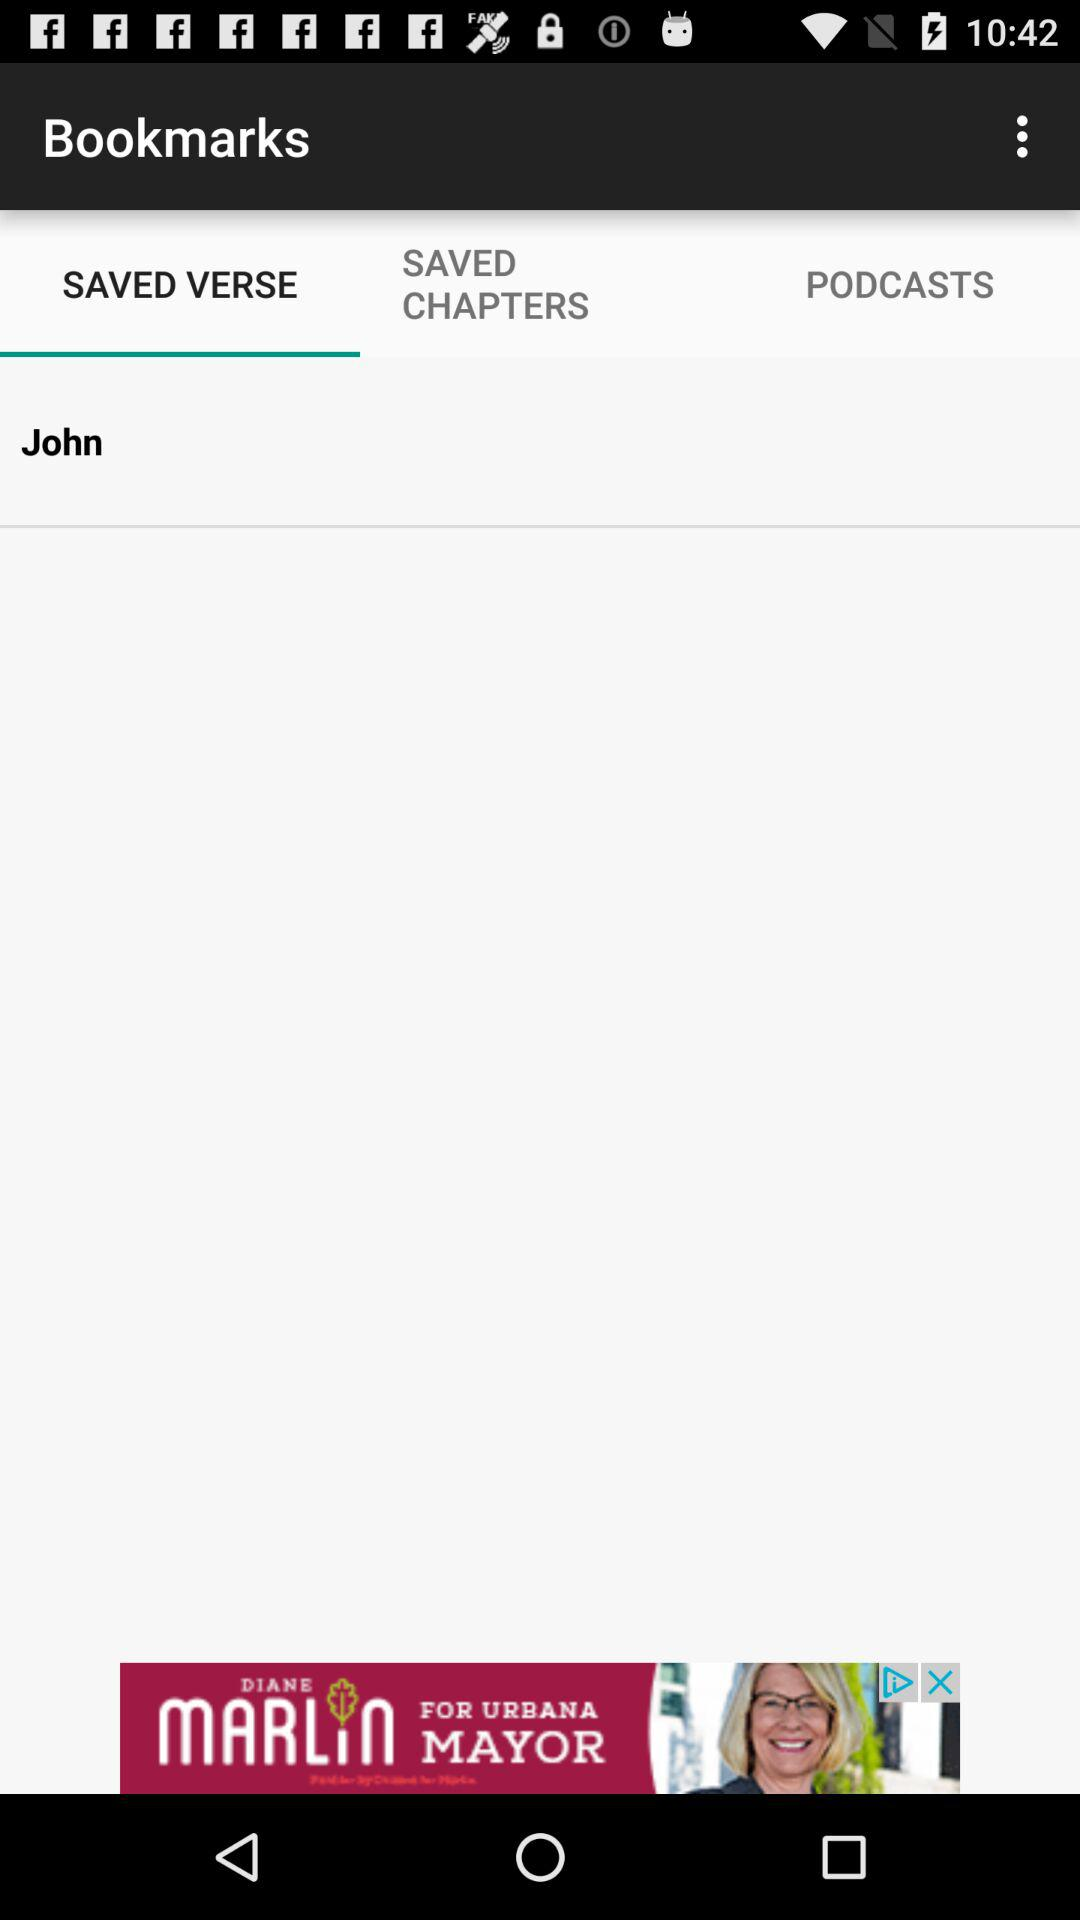What is the selected tab? The selected tab is " SAVED VERSE". 